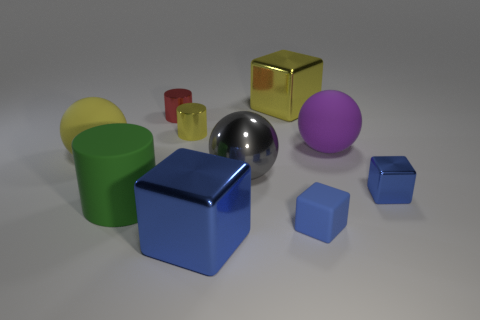Subtract all metal cylinders. How many cylinders are left? 1 Subtract all green cylinders. How many blue blocks are left? 3 Subtract 1 blocks. How many blocks are left? 3 Subtract all yellow blocks. How many blocks are left? 3 Subtract all green balls. Subtract all cyan cylinders. How many balls are left? 3 Add 8 big yellow rubber blocks. How many big yellow rubber blocks exist? 8 Subtract 2 blue cubes. How many objects are left? 8 Subtract all cylinders. How many objects are left? 7 Subtract all yellow cylinders. Subtract all blocks. How many objects are left? 5 Add 1 big rubber cylinders. How many big rubber cylinders are left? 2 